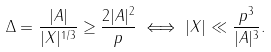<formula> <loc_0><loc_0><loc_500><loc_500>\Delta = \frac { | A | } { | X | ^ { 1 / 3 } } \geq \frac { 2 | A | ^ { 2 } } p \iff | X | \ll \frac { p ^ { 3 } } { | A | ^ { 3 } } .</formula> 